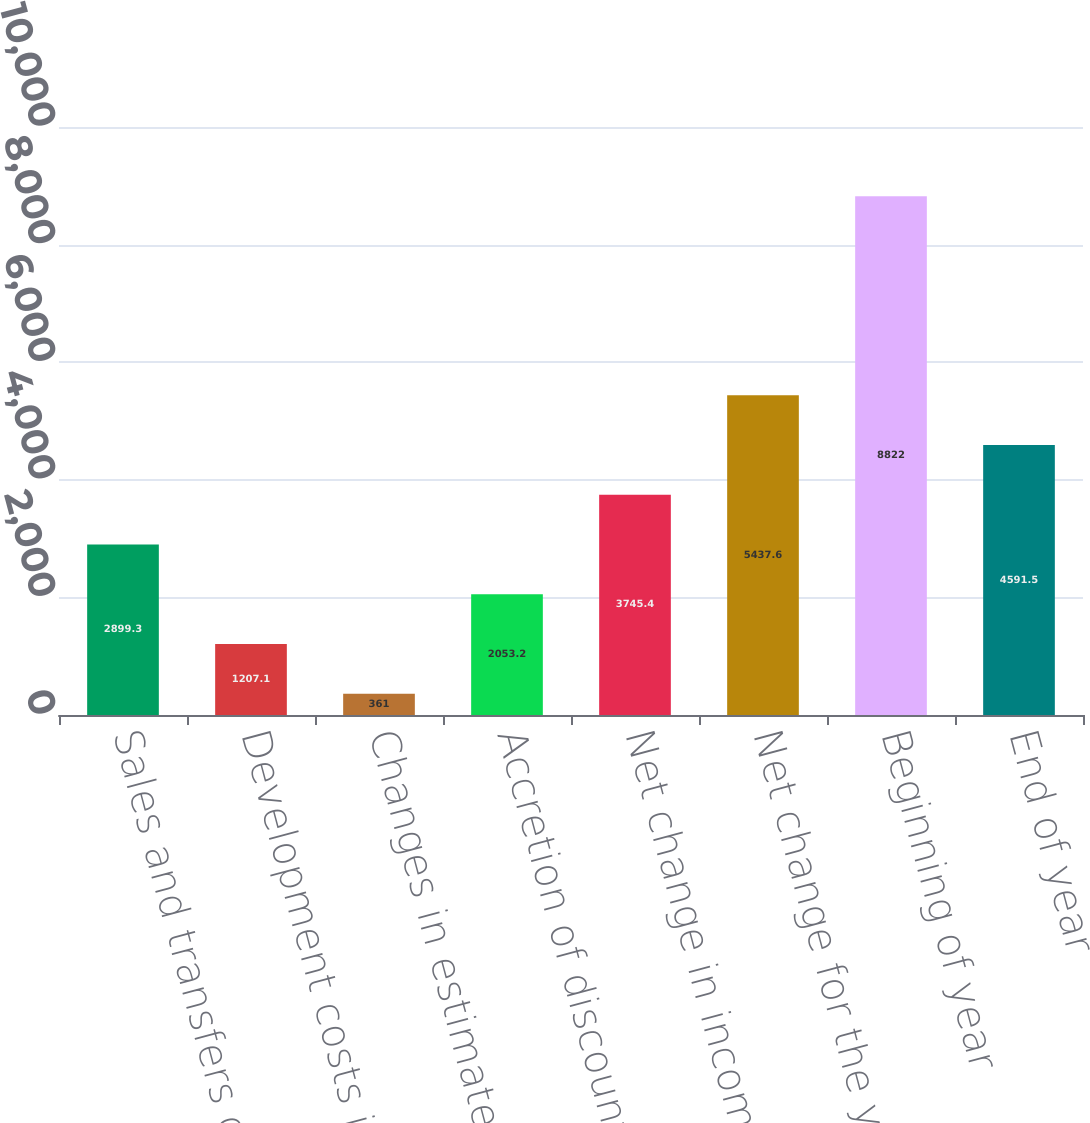Convert chart. <chart><loc_0><loc_0><loc_500><loc_500><bar_chart><fcel>Sales and transfers of oil and<fcel>Development costs incurred<fcel>Changes in estimated future<fcel>Accretion of discount<fcel>Net change in income taxes<fcel>Net change for the year<fcel>Beginning of year<fcel>End of year<nl><fcel>2899.3<fcel>1207.1<fcel>361<fcel>2053.2<fcel>3745.4<fcel>5437.6<fcel>8822<fcel>4591.5<nl></chart> 